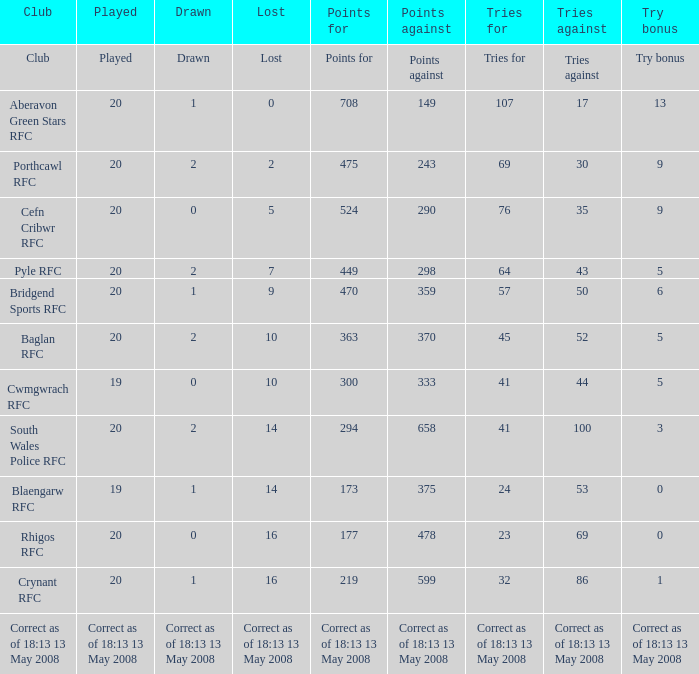Which organization has a played count of 19, and the loss of 14? Blaengarw RFC. 